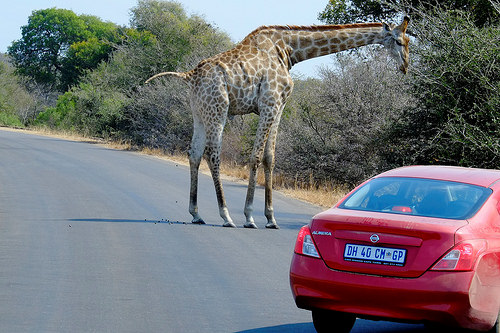<image>
Can you confirm if the animal is to the right of the car? No. The animal is not to the right of the car. The horizontal positioning shows a different relationship. 